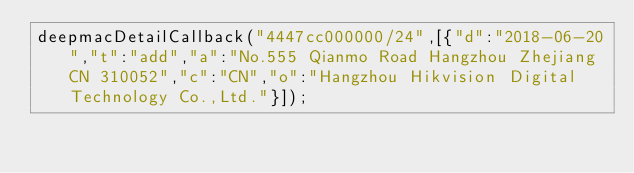Convert code to text. <code><loc_0><loc_0><loc_500><loc_500><_JavaScript_>deepmacDetailCallback("4447cc000000/24",[{"d":"2018-06-20","t":"add","a":"No.555 Qianmo Road Hangzhou Zhejiang CN 310052","c":"CN","o":"Hangzhou Hikvision Digital Technology Co.,Ltd."}]);
</code> 